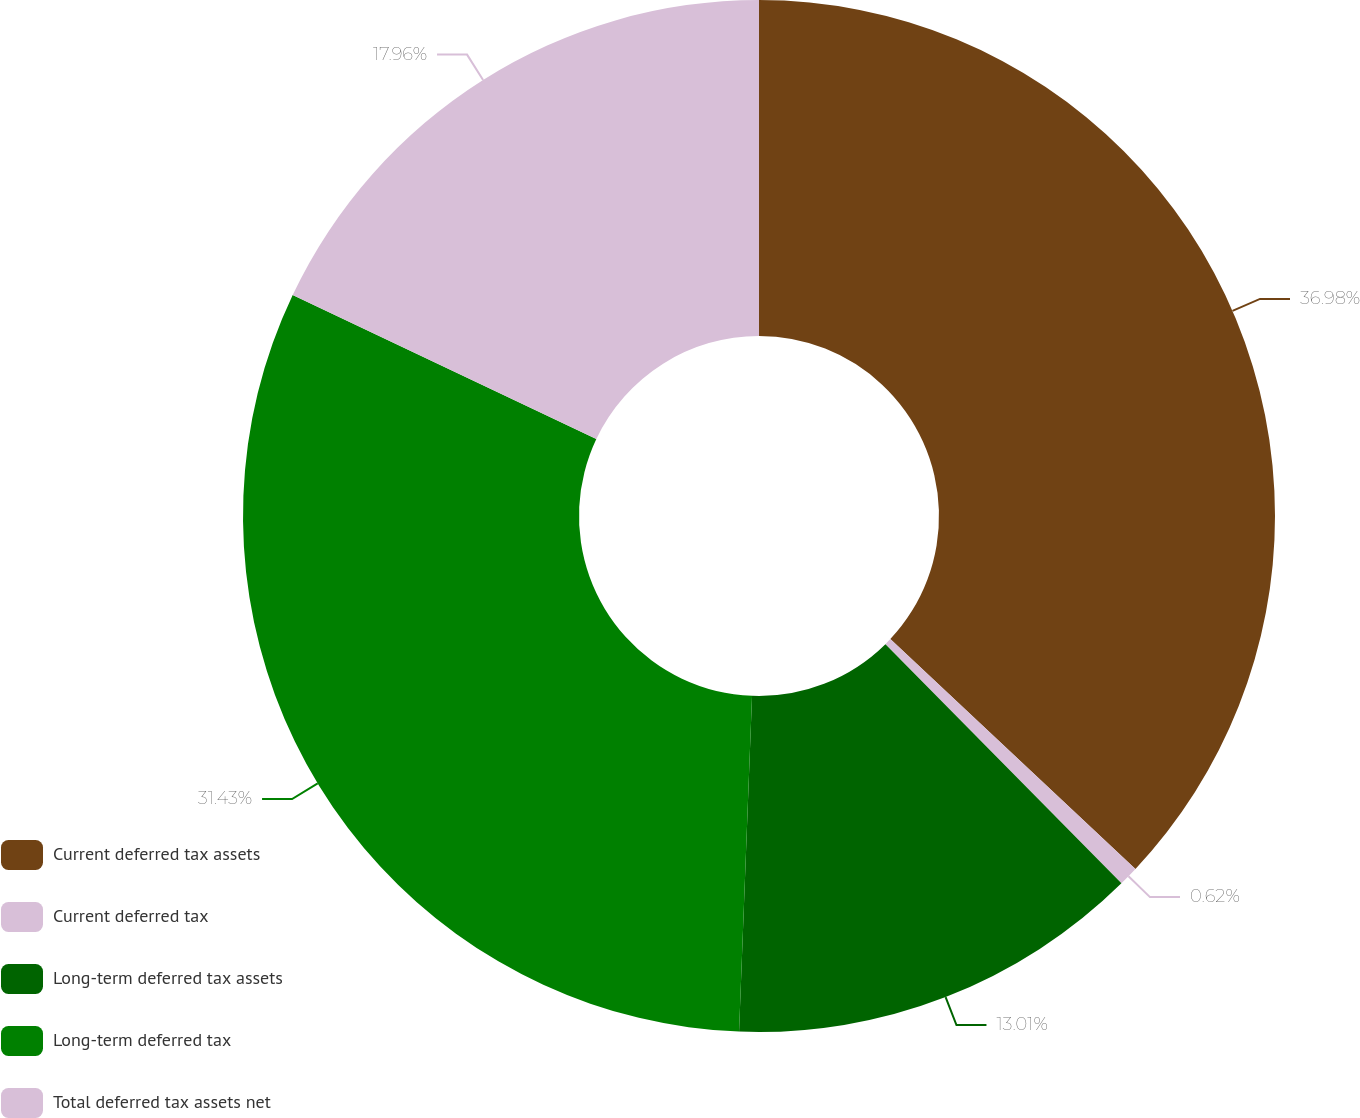Convert chart. <chart><loc_0><loc_0><loc_500><loc_500><pie_chart><fcel>Current deferred tax assets<fcel>Current deferred tax<fcel>Long-term deferred tax assets<fcel>Long-term deferred tax<fcel>Total deferred tax assets net<nl><fcel>36.99%<fcel>0.62%<fcel>13.01%<fcel>31.43%<fcel>17.96%<nl></chart> 